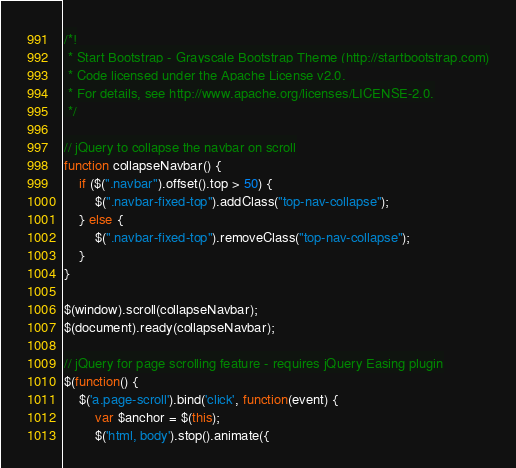Convert code to text. <code><loc_0><loc_0><loc_500><loc_500><_JavaScript_>/*!
 * Start Bootstrap - Grayscale Bootstrap Theme (http://startbootstrap.com)
 * Code licensed under the Apache License v2.0.
 * For details, see http://www.apache.org/licenses/LICENSE-2.0.
 */

// jQuery to collapse the navbar on scroll
function collapseNavbar() {
    if ($(".navbar").offset().top > 50) {
        $(".navbar-fixed-top").addClass("top-nav-collapse");
    } else {
        $(".navbar-fixed-top").removeClass("top-nav-collapse");
    }
}

$(window).scroll(collapseNavbar);
$(document).ready(collapseNavbar);

// jQuery for page scrolling feature - requires jQuery Easing plugin
$(function() {
    $('a.page-scroll').bind('click', function(event) {
        var $anchor = $(this);
        $('html, body').stop().animate({</code> 